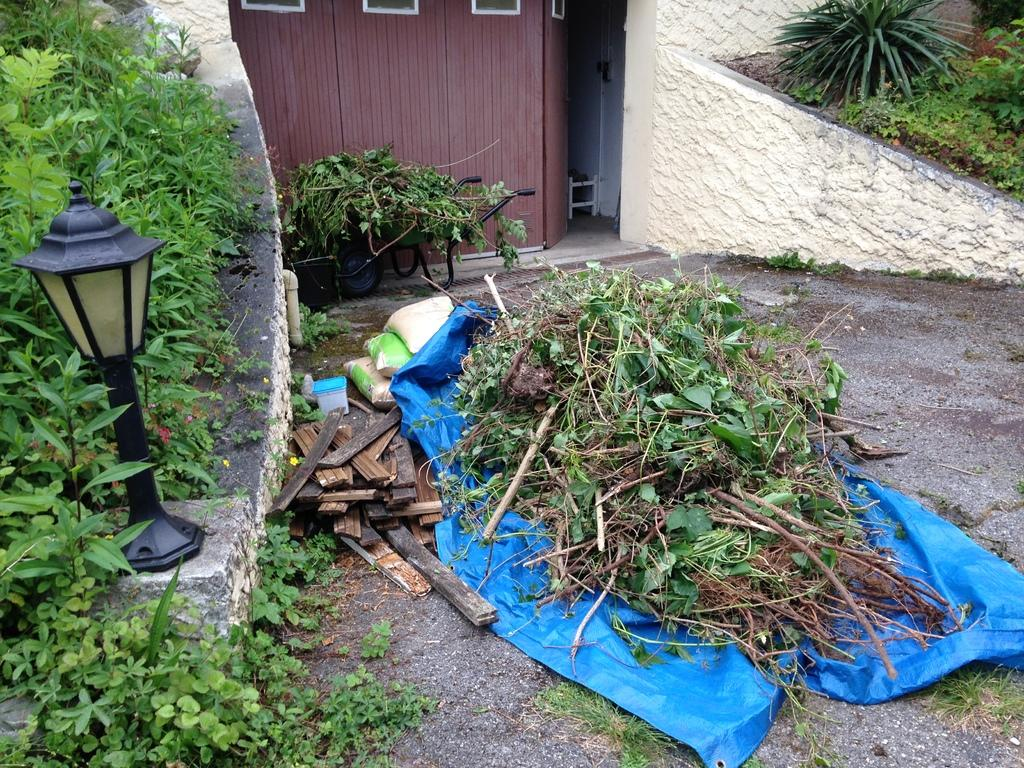What is the main object in the image that has stems and leaves on it? There is a cover in the image that has stems and leaves on it. What type of structure can be seen in the image? There is a door in the image. What type of vegetation is present in the image? There are plants and trees in the image. What type of lighting is present in the image? There is a lamp in the image. Where is the frog sitting in the image? There is no frog present in the image. What type of party is being held in the image? There is no party depicted in the image. 